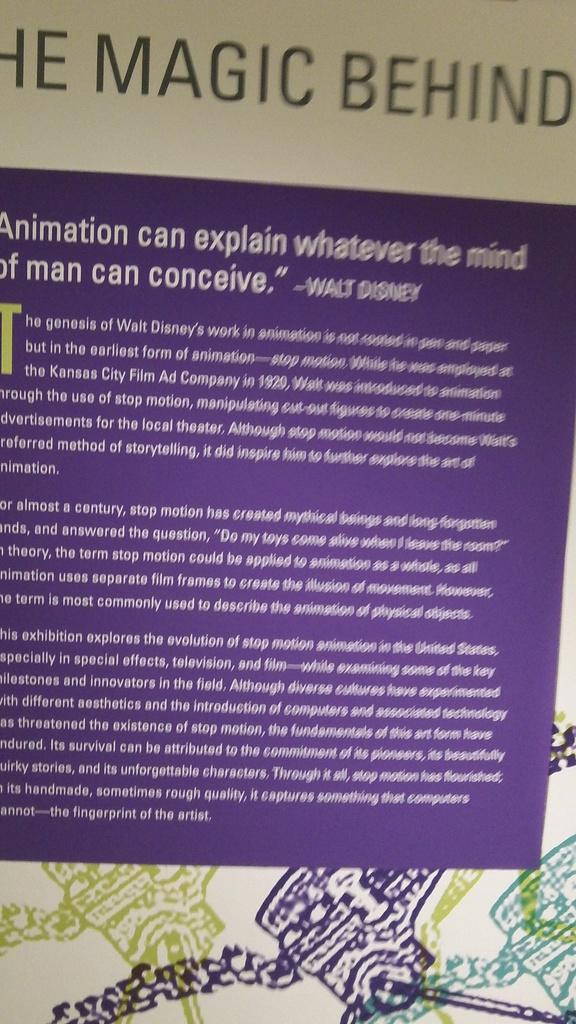<image>
Relay a brief, clear account of the picture shown. The document here explains about the magic behind. 